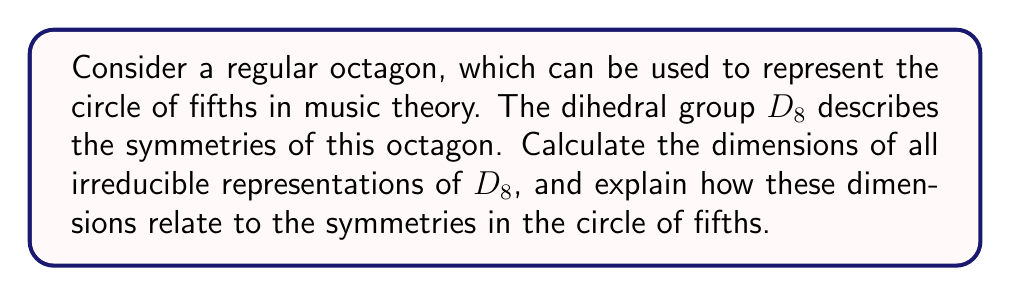Help me with this question. To find the dimensions of irreducible representations for $D_8$, we follow these steps:

1) The order of $D_8$ is $|D_8| = 16$, as it has 8 rotations and 8 reflections.

2) $D_8$ has 5 conjugacy classes:
   - Identity: $\{e\}$
   - 180° rotation: $\{r^4\}$
   - 90° and 270° rotations: $\{r^2, r^6\}$
   - 45°, 135°, 225°, 315° rotations: $\{r, r^3, r^5, r^7\}$
   - 8 reflections: $\{s, sr, sr^2, sr^3, sr^4, sr^5, sr^6, sr^7\}$

3) The number of irreducible representations equals the number of conjugacy classes, so there are 5 irreducible representations.

4) By the class equation:
   $$16 = \sum_{i=1}^5 d_i^2$$
   where $d_i$ are the dimensions of the irreducible representations.

5) $D_8$ is non-abelian, so it must have at least one 2-dimensional representation. The only solution to the equation that fits this constraint is:
   $$16 = 1^2 + 1^2 + 1^2 + 1^2 + 2^2$$

6) Thus, $D_8$ has four 1-dimensional representations and one 2-dimensional representation.

Relating to musical symmetry:
- The four 1-dimensional representations correspond to the invariance under 180° rotation (tritone relationship) and reflection (inversion).
- The 2-dimensional representation captures the more complex symmetries, such as rotations by 45° (corresponding to movement by perfect fourths/fifths in the circle of fifths) and other reflections.

This structure reflects the fundamental symmetries in the circle of fifths, including the special role of the tritone and the importance of fourth/fifth relationships in tonal harmony.
Answer: Four 1-dimensional and one 2-dimensional irreducible representations. 